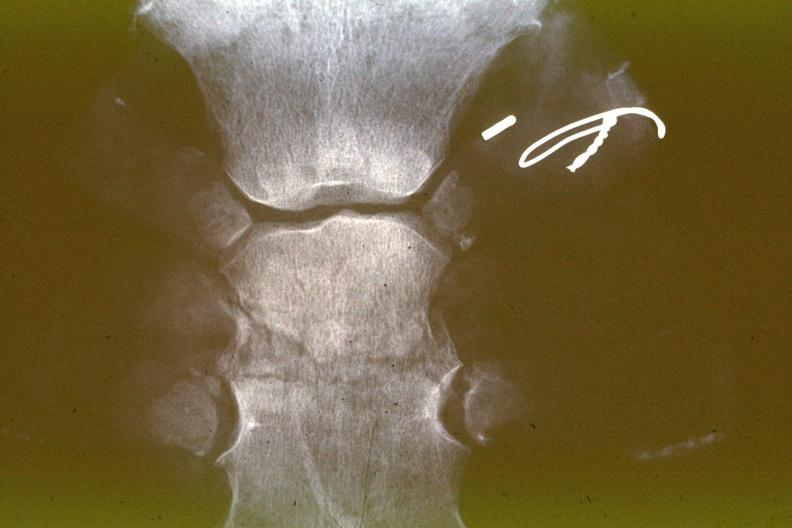what does this image show?
Answer the question using a single word or phrase. X-ray sternum healing fracture 15 days 